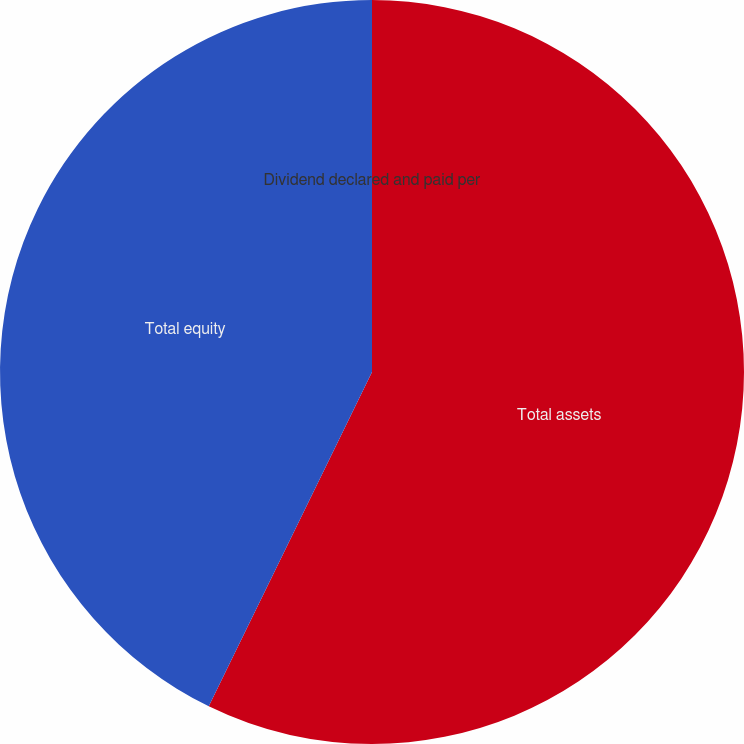<chart> <loc_0><loc_0><loc_500><loc_500><pie_chart><fcel>Total assets<fcel>Total equity<fcel>Dividend declared and paid per<nl><fcel>57.23%<fcel>42.77%<fcel>0.0%<nl></chart> 